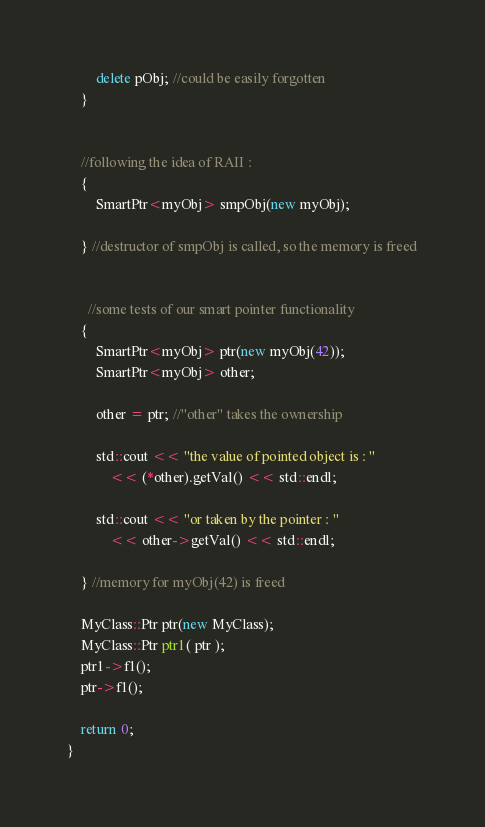<code> <loc_0><loc_0><loc_500><loc_500><_C++_>
		delete pObj; //could be easily forgotten
	}


	//following the idea of RAII :
	{
		SmartPtr<myObj> smpObj(new myObj);

	} //destructor of smpObj is called, so the memory is freed


	  //some tests of our smart pointer functionality 
	{
		SmartPtr<myObj> ptr(new myObj(42));
		SmartPtr<myObj> other;

		other = ptr; //"other" takes the ownership

		std::cout << "the value of pointed object is : " 
			<< (*other).getVal() << std::endl;

		std::cout << "or taken by the pointer : "
			<< other->getVal() << std::endl;

	} //memory for myObj(42) is freed 

	MyClass::Ptr ptr(new MyClass);
	MyClass::Ptr ptr1( ptr );
	ptr1->f1();
	ptr->f1();

	return 0;
}</code> 